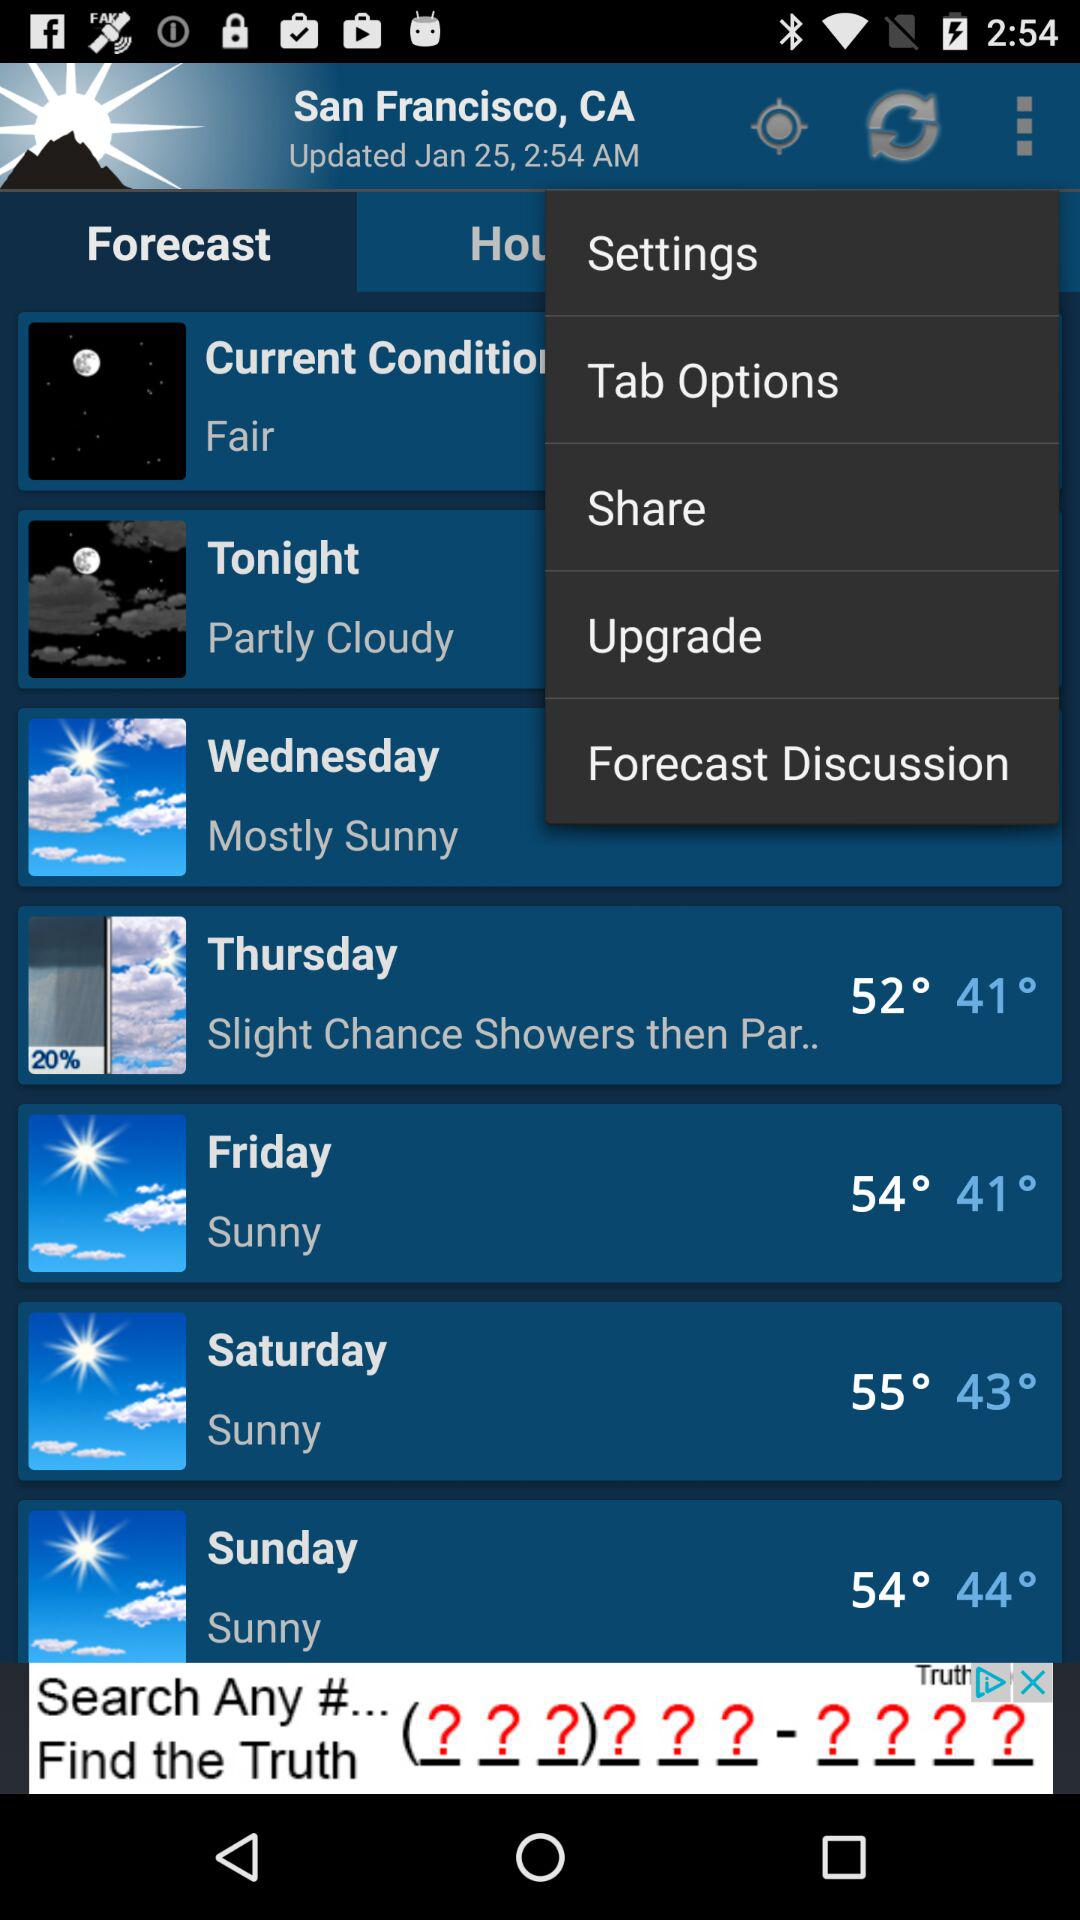How is the weather tonight? The weather is "Partly Cloudy". 